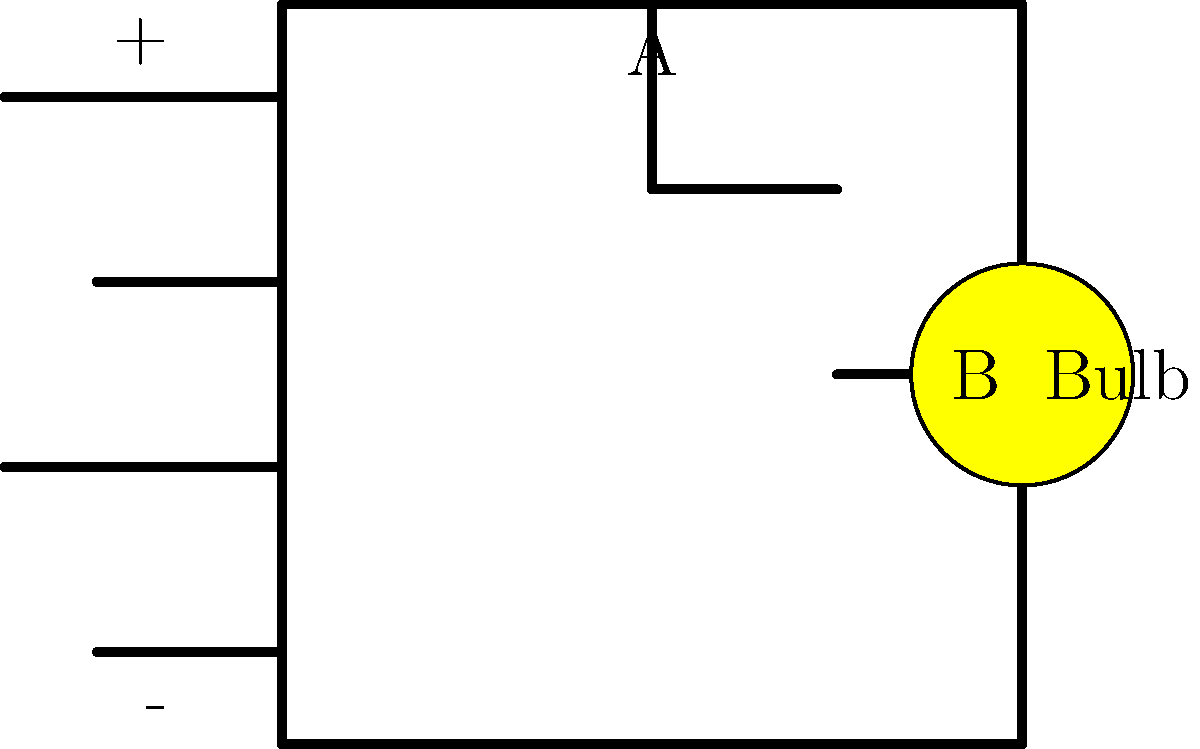In this magical time-traveling circuit, we have two switches (A and B) controlling a light bulb. If both switches need to be closed for the bulb to light up, which path will the electricity take when the bulb is shining brightly? Let's follow the path of electricity step-by-step:

1. Electricity always flows from the positive (+) terminal of the battery to the negative (-) terminal.

2. Starting from the positive terminal, the electricity first reaches Switch A.

3. For the bulb to light up, Switch A must be closed. So, the electricity passes through Switch A.

4. After passing Switch A, the electricity continues along the wire to Switch B.

5. Switch B must also be closed for the bulb to light up. So, the electricity passes through Switch B.

6. After passing Switch B, the electricity reaches the light bulb, making it shine brightly.

7. From the light bulb, the electricity continues its journey back to the negative terminal of the battery.

This type of circuit is called a "series circuit" because the switches and the bulb are connected one after another, like a line of people holding hands.

Remember, both switches need to be closed (like magical gates in our time-traveling adventure) for the electricity to complete its journey and light up the bulb!
Answer: Battery (+) → Switch A → Switch B → Bulb → Battery (-) 